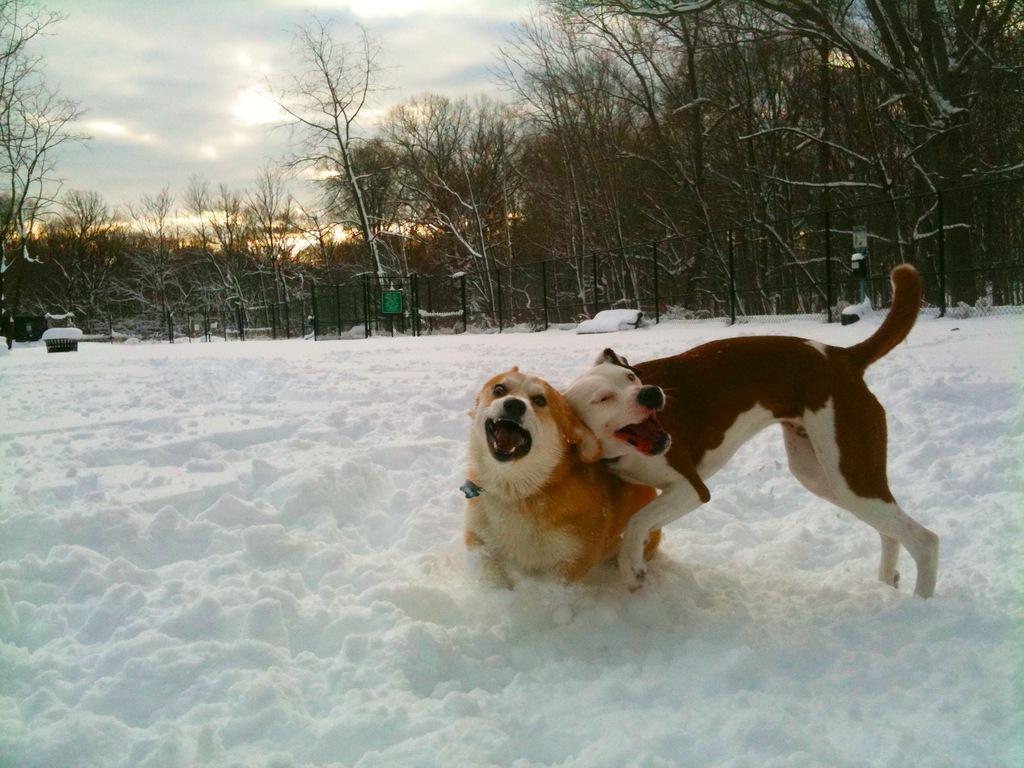How would you summarize this image in a sentence or two? In this image I can see the dogs in the snow. In the background, I can see the trees and clouds in the sky. 